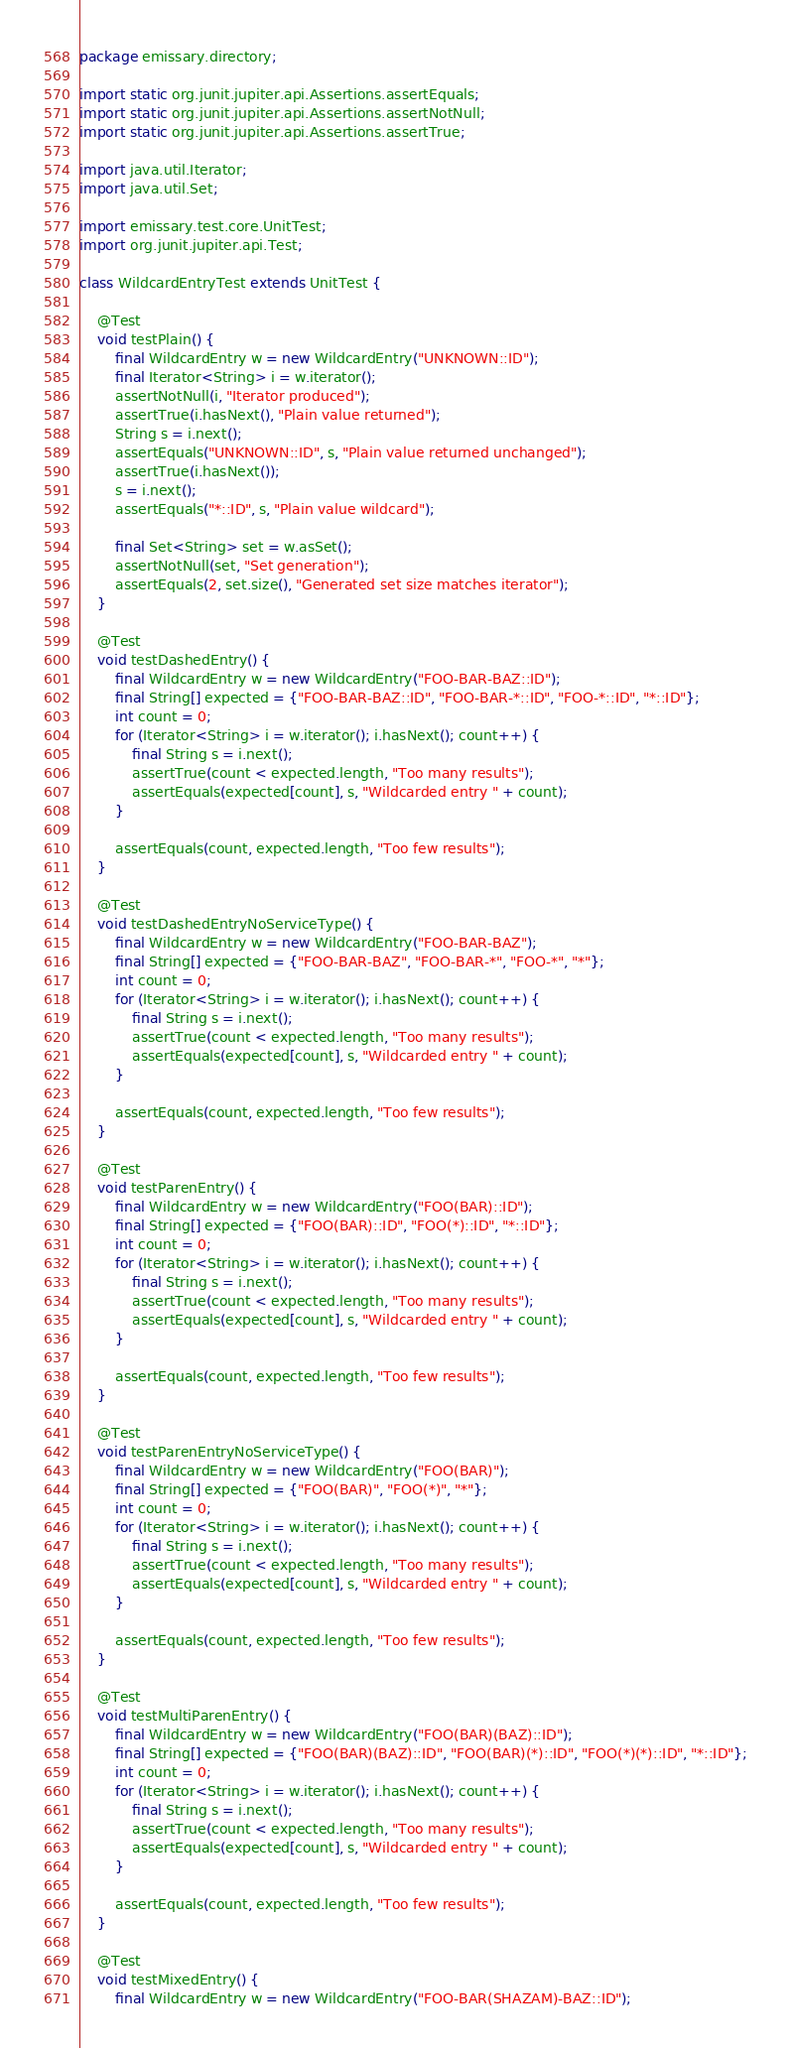Convert code to text. <code><loc_0><loc_0><loc_500><loc_500><_Java_>package emissary.directory;

import static org.junit.jupiter.api.Assertions.assertEquals;
import static org.junit.jupiter.api.Assertions.assertNotNull;
import static org.junit.jupiter.api.Assertions.assertTrue;

import java.util.Iterator;
import java.util.Set;

import emissary.test.core.UnitTest;
import org.junit.jupiter.api.Test;

class WildcardEntryTest extends UnitTest {

    @Test
    void testPlain() {
        final WildcardEntry w = new WildcardEntry("UNKNOWN::ID");
        final Iterator<String> i = w.iterator();
        assertNotNull(i, "Iterator produced");
        assertTrue(i.hasNext(), "Plain value returned");
        String s = i.next();
        assertEquals("UNKNOWN::ID", s, "Plain value returned unchanged");
        assertTrue(i.hasNext());
        s = i.next();
        assertEquals("*::ID", s, "Plain value wildcard");

        final Set<String> set = w.asSet();
        assertNotNull(set, "Set generation");
        assertEquals(2, set.size(), "Generated set size matches iterator");
    }

    @Test
    void testDashedEntry() {
        final WildcardEntry w = new WildcardEntry("FOO-BAR-BAZ::ID");
        final String[] expected = {"FOO-BAR-BAZ::ID", "FOO-BAR-*::ID", "FOO-*::ID", "*::ID"};
        int count = 0;
        for (Iterator<String> i = w.iterator(); i.hasNext(); count++) {
            final String s = i.next();
            assertTrue(count < expected.length, "Too many results");
            assertEquals(expected[count], s, "Wildcarded entry " + count);
        }

        assertEquals(count, expected.length, "Too few results");
    }

    @Test
    void testDashedEntryNoServiceType() {
        final WildcardEntry w = new WildcardEntry("FOO-BAR-BAZ");
        final String[] expected = {"FOO-BAR-BAZ", "FOO-BAR-*", "FOO-*", "*"};
        int count = 0;
        for (Iterator<String> i = w.iterator(); i.hasNext(); count++) {
            final String s = i.next();
            assertTrue(count < expected.length, "Too many results");
            assertEquals(expected[count], s, "Wildcarded entry " + count);
        }

        assertEquals(count, expected.length, "Too few results");
    }

    @Test
    void testParenEntry() {
        final WildcardEntry w = new WildcardEntry("FOO(BAR)::ID");
        final String[] expected = {"FOO(BAR)::ID", "FOO(*)::ID", "*::ID"};
        int count = 0;
        for (Iterator<String> i = w.iterator(); i.hasNext(); count++) {
            final String s = i.next();
            assertTrue(count < expected.length, "Too many results");
            assertEquals(expected[count], s, "Wildcarded entry " + count);
        }

        assertEquals(count, expected.length, "Too few results");
    }

    @Test
    void testParenEntryNoServiceType() {
        final WildcardEntry w = new WildcardEntry("FOO(BAR)");
        final String[] expected = {"FOO(BAR)", "FOO(*)", "*"};
        int count = 0;
        for (Iterator<String> i = w.iterator(); i.hasNext(); count++) {
            final String s = i.next();
            assertTrue(count < expected.length, "Too many results");
            assertEquals(expected[count], s, "Wildcarded entry " + count);
        }

        assertEquals(count, expected.length, "Too few results");
    }

    @Test
    void testMultiParenEntry() {
        final WildcardEntry w = new WildcardEntry("FOO(BAR)(BAZ)::ID");
        final String[] expected = {"FOO(BAR)(BAZ)::ID", "FOO(BAR)(*)::ID", "FOO(*)(*)::ID", "*::ID"};
        int count = 0;
        for (Iterator<String> i = w.iterator(); i.hasNext(); count++) {
            final String s = i.next();
            assertTrue(count < expected.length, "Too many results");
            assertEquals(expected[count], s, "Wildcarded entry " + count);
        }

        assertEquals(count, expected.length, "Too few results");
    }

    @Test
    void testMixedEntry() {
        final WildcardEntry w = new WildcardEntry("FOO-BAR(SHAZAM)-BAZ::ID");</code> 